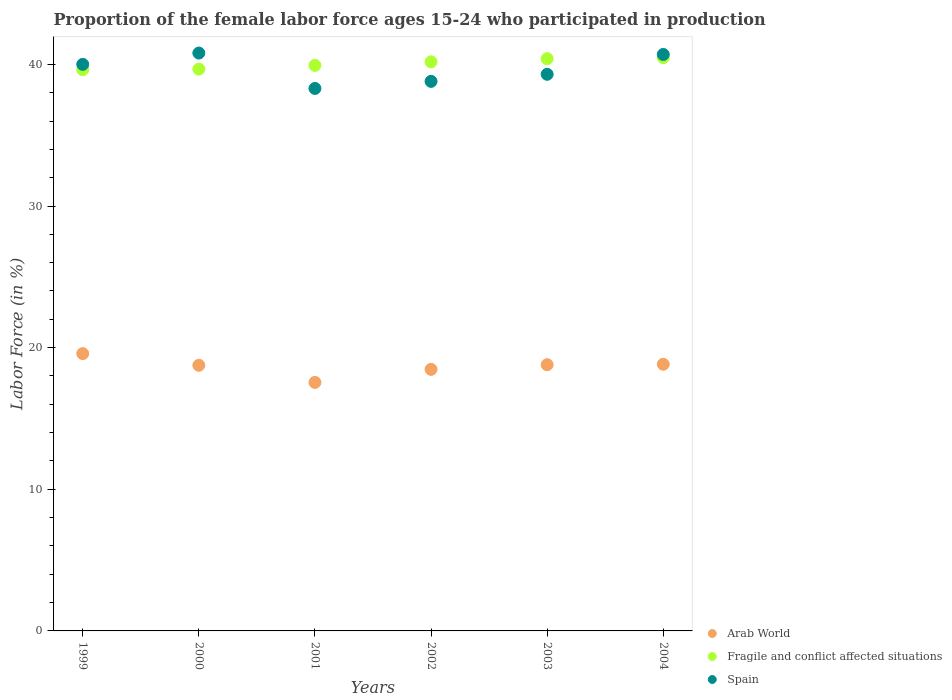How many different coloured dotlines are there?
Ensure brevity in your answer.  3. Is the number of dotlines equal to the number of legend labels?
Give a very brief answer. Yes. What is the proportion of the female labor force who participated in production in Arab World in 1999?
Your response must be concise. 19.58. Across all years, what is the maximum proportion of the female labor force who participated in production in Spain?
Your answer should be compact. 40.8. Across all years, what is the minimum proportion of the female labor force who participated in production in Fragile and conflict affected situations?
Your answer should be very brief. 39.63. In which year was the proportion of the female labor force who participated in production in Arab World maximum?
Make the answer very short. 1999. What is the total proportion of the female labor force who participated in production in Fragile and conflict affected situations in the graph?
Keep it short and to the point. 240.28. What is the difference between the proportion of the female labor force who participated in production in Spain in 2003 and the proportion of the female labor force who participated in production in Arab World in 2001?
Keep it short and to the point. 21.75. What is the average proportion of the female labor force who participated in production in Fragile and conflict affected situations per year?
Provide a succinct answer. 40.05. In the year 2003, what is the difference between the proportion of the female labor force who participated in production in Spain and proportion of the female labor force who participated in production in Arab World?
Offer a terse response. 20.5. What is the ratio of the proportion of the female labor force who participated in production in Spain in 2001 to that in 2004?
Give a very brief answer. 0.94. Is the difference between the proportion of the female labor force who participated in production in Spain in 2000 and 2002 greater than the difference between the proportion of the female labor force who participated in production in Arab World in 2000 and 2002?
Keep it short and to the point. Yes. What is the difference between the highest and the second highest proportion of the female labor force who participated in production in Spain?
Give a very brief answer. 0.1. What is the difference between the highest and the lowest proportion of the female labor force who participated in production in Spain?
Make the answer very short. 2.5. Is the sum of the proportion of the female labor force who participated in production in Fragile and conflict affected situations in 2002 and 2003 greater than the maximum proportion of the female labor force who participated in production in Arab World across all years?
Make the answer very short. Yes. Is it the case that in every year, the sum of the proportion of the female labor force who participated in production in Arab World and proportion of the female labor force who participated in production in Fragile and conflict affected situations  is greater than the proportion of the female labor force who participated in production in Spain?
Your response must be concise. Yes. Does the proportion of the female labor force who participated in production in Spain monotonically increase over the years?
Make the answer very short. No. Is the proportion of the female labor force who participated in production in Fragile and conflict affected situations strictly greater than the proportion of the female labor force who participated in production in Arab World over the years?
Give a very brief answer. Yes. Is the proportion of the female labor force who participated in production in Spain strictly less than the proportion of the female labor force who participated in production in Arab World over the years?
Your answer should be compact. No. How many dotlines are there?
Your answer should be very brief. 3. How many years are there in the graph?
Ensure brevity in your answer.  6. What is the difference between two consecutive major ticks on the Y-axis?
Offer a very short reply. 10. Does the graph contain any zero values?
Provide a succinct answer. No. Does the graph contain grids?
Provide a succinct answer. No. How are the legend labels stacked?
Provide a short and direct response. Vertical. What is the title of the graph?
Provide a short and direct response. Proportion of the female labor force ages 15-24 who participated in production. Does "Pakistan" appear as one of the legend labels in the graph?
Keep it short and to the point. No. What is the label or title of the Y-axis?
Offer a terse response. Labor Force (in %). What is the Labor Force (in %) of Arab World in 1999?
Your answer should be compact. 19.58. What is the Labor Force (in %) in Fragile and conflict affected situations in 1999?
Offer a very short reply. 39.63. What is the Labor Force (in %) in Arab World in 2000?
Give a very brief answer. 18.75. What is the Labor Force (in %) in Fragile and conflict affected situations in 2000?
Provide a short and direct response. 39.67. What is the Labor Force (in %) of Spain in 2000?
Your answer should be compact. 40.8. What is the Labor Force (in %) in Arab World in 2001?
Give a very brief answer. 17.55. What is the Labor Force (in %) of Fragile and conflict affected situations in 2001?
Offer a very short reply. 39.93. What is the Labor Force (in %) in Spain in 2001?
Keep it short and to the point. 38.3. What is the Labor Force (in %) in Arab World in 2002?
Your answer should be very brief. 18.47. What is the Labor Force (in %) of Fragile and conflict affected situations in 2002?
Give a very brief answer. 40.18. What is the Labor Force (in %) in Spain in 2002?
Your response must be concise. 38.8. What is the Labor Force (in %) of Arab World in 2003?
Give a very brief answer. 18.8. What is the Labor Force (in %) in Fragile and conflict affected situations in 2003?
Give a very brief answer. 40.4. What is the Labor Force (in %) of Spain in 2003?
Your answer should be very brief. 39.3. What is the Labor Force (in %) of Arab World in 2004?
Make the answer very short. 18.83. What is the Labor Force (in %) of Fragile and conflict affected situations in 2004?
Your answer should be compact. 40.48. What is the Labor Force (in %) of Spain in 2004?
Keep it short and to the point. 40.7. Across all years, what is the maximum Labor Force (in %) in Arab World?
Keep it short and to the point. 19.58. Across all years, what is the maximum Labor Force (in %) of Fragile and conflict affected situations?
Offer a very short reply. 40.48. Across all years, what is the maximum Labor Force (in %) in Spain?
Keep it short and to the point. 40.8. Across all years, what is the minimum Labor Force (in %) in Arab World?
Your answer should be compact. 17.55. Across all years, what is the minimum Labor Force (in %) in Fragile and conflict affected situations?
Offer a very short reply. 39.63. Across all years, what is the minimum Labor Force (in %) in Spain?
Provide a succinct answer. 38.3. What is the total Labor Force (in %) in Arab World in the graph?
Your answer should be compact. 111.97. What is the total Labor Force (in %) of Fragile and conflict affected situations in the graph?
Your answer should be compact. 240.28. What is the total Labor Force (in %) in Spain in the graph?
Make the answer very short. 237.9. What is the difference between the Labor Force (in %) in Arab World in 1999 and that in 2000?
Your answer should be very brief. 0.83. What is the difference between the Labor Force (in %) in Fragile and conflict affected situations in 1999 and that in 2000?
Provide a short and direct response. -0.04. What is the difference between the Labor Force (in %) in Spain in 1999 and that in 2000?
Make the answer very short. -0.8. What is the difference between the Labor Force (in %) in Arab World in 1999 and that in 2001?
Offer a very short reply. 2.03. What is the difference between the Labor Force (in %) of Fragile and conflict affected situations in 1999 and that in 2001?
Make the answer very short. -0.3. What is the difference between the Labor Force (in %) in Arab World in 1999 and that in 2002?
Offer a very short reply. 1.11. What is the difference between the Labor Force (in %) of Fragile and conflict affected situations in 1999 and that in 2002?
Give a very brief answer. -0.55. What is the difference between the Labor Force (in %) of Arab World in 1999 and that in 2003?
Provide a succinct answer. 0.78. What is the difference between the Labor Force (in %) of Fragile and conflict affected situations in 1999 and that in 2003?
Make the answer very short. -0.78. What is the difference between the Labor Force (in %) in Arab World in 1999 and that in 2004?
Give a very brief answer. 0.75. What is the difference between the Labor Force (in %) in Fragile and conflict affected situations in 1999 and that in 2004?
Provide a succinct answer. -0.85. What is the difference between the Labor Force (in %) of Spain in 1999 and that in 2004?
Give a very brief answer. -0.7. What is the difference between the Labor Force (in %) in Arab World in 2000 and that in 2001?
Ensure brevity in your answer.  1.21. What is the difference between the Labor Force (in %) of Fragile and conflict affected situations in 2000 and that in 2001?
Give a very brief answer. -0.26. What is the difference between the Labor Force (in %) of Arab World in 2000 and that in 2002?
Ensure brevity in your answer.  0.29. What is the difference between the Labor Force (in %) of Fragile and conflict affected situations in 2000 and that in 2002?
Your response must be concise. -0.51. What is the difference between the Labor Force (in %) of Spain in 2000 and that in 2002?
Give a very brief answer. 2. What is the difference between the Labor Force (in %) of Arab World in 2000 and that in 2003?
Your answer should be compact. -0.04. What is the difference between the Labor Force (in %) of Fragile and conflict affected situations in 2000 and that in 2003?
Your response must be concise. -0.73. What is the difference between the Labor Force (in %) of Spain in 2000 and that in 2003?
Provide a short and direct response. 1.5. What is the difference between the Labor Force (in %) in Arab World in 2000 and that in 2004?
Ensure brevity in your answer.  -0.07. What is the difference between the Labor Force (in %) in Fragile and conflict affected situations in 2000 and that in 2004?
Ensure brevity in your answer.  -0.81. What is the difference between the Labor Force (in %) in Spain in 2000 and that in 2004?
Provide a succinct answer. 0.1. What is the difference between the Labor Force (in %) in Arab World in 2001 and that in 2002?
Your answer should be compact. -0.92. What is the difference between the Labor Force (in %) of Fragile and conflict affected situations in 2001 and that in 2002?
Offer a very short reply. -0.25. What is the difference between the Labor Force (in %) of Spain in 2001 and that in 2002?
Your answer should be very brief. -0.5. What is the difference between the Labor Force (in %) of Arab World in 2001 and that in 2003?
Your response must be concise. -1.25. What is the difference between the Labor Force (in %) in Fragile and conflict affected situations in 2001 and that in 2003?
Offer a very short reply. -0.47. What is the difference between the Labor Force (in %) of Spain in 2001 and that in 2003?
Make the answer very short. -1. What is the difference between the Labor Force (in %) in Arab World in 2001 and that in 2004?
Offer a very short reply. -1.28. What is the difference between the Labor Force (in %) of Fragile and conflict affected situations in 2001 and that in 2004?
Offer a terse response. -0.55. What is the difference between the Labor Force (in %) of Spain in 2001 and that in 2004?
Provide a short and direct response. -2.4. What is the difference between the Labor Force (in %) of Arab World in 2002 and that in 2003?
Keep it short and to the point. -0.33. What is the difference between the Labor Force (in %) in Fragile and conflict affected situations in 2002 and that in 2003?
Ensure brevity in your answer.  -0.22. What is the difference between the Labor Force (in %) in Arab World in 2002 and that in 2004?
Your answer should be very brief. -0.36. What is the difference between the Labor Force (in %) of Fragile and conflict affected situations in 2002 and that in 2004?
Provide a succinct answer. -0.3. What is the difference between the Labor Force (in %) in Arab World in 2003 and that in 2004?
Offer a terse response. -0.03. What is the difference between the Labor Force (in %) of Fragile and conflict affected situations in 2003 and that in 2004?
Give a very brief answer. -0.08. What is the difference between the Labor Force (in %) of Arab World in 1999 and the Labor Force (in %) of Fragile and conflict affected situations in 2000?
Provide a succinct answer. -20.09. What is the difference between the Labor Force (in %) in Arab World in 1999 and the Labor Force (in %) in Spain in 2000?
Provide a succinct answer. -21.22. What is the difference between the Labor Force (in %) of Fragile and conflict affected situations in 1999 and the Labor Force (in %) of Spain in 2000?
Offer a terse response. -1.17. What is the difference between the Labor Force (in %) of Arab World in 1999 and the Labor Force (in %) of Fragile and conflict affected situations in 2001?
Offer a terse response. -20.35. What is the difference between the Labor Force (in %) in Arab World in 1999 and the Labor Force (in %) in Spain in 2001?
Your answer should be compact. -18.72. What is the difference between the Labor Force (in %) in Fragile and conflict affected situations in 1999 and the Labor Force (in %) in Spain in 2001?
Keep it short and to the point. 1.33. What is the difference between the Labor Force (in %) in Arab World in 1999 and the Labor Force (in %) in Fragile and conflict affected situations in 2002?
Provide a succinct answer. -20.6. What is the difference between the Labor Force (in %) in Arab World in 1999 and the Labor Force (in %) in Spain in 2002?
Provide a short and direct response. -19.22. What is the difference between the Labor Force (in %) of Fragile and conflict affected situations in 1999 and the Labor Force (in %) of Spain in 2002?
Your answer should be compact. 0.83. What is the difference between the Labor Force (in %) of Arab World in 1999 and the Labor Force (in %) of Fragile and conflict affected situations in 2003?
Make the answer very short. -20.82. What is the difference between the Labor Force (in %) in Arab World in 1999 and the Labor Force (in %) in Spain in 2003?
Offer a terse response. -19.72. What is the difference between the Labor Force (in %) of Fragile and conflict affected situations in 1999 and the Labor Force (in %) of Spain in 2003?
Give a very brief answer. 0.33. What is the difference between the Labor Force (in %) in Arab World in 1999 and the Labor Force (in %) in Fragile and conflict affected situations in 2004?
Keep it short and to the point. -20.9. What is the difference between the Labor Force (in %) in Arab World in 1999 and the Labor Force (in %) in Spain in 2004?
Make the answer very short. -21.12. What is the difference between the Labor Force (in %) of Fragile and conflict affected situations in 1999 and the Labor Force (in %) of Spain in 2004?
Provide a short and direct response. -1.07. What is the difference between the Labor Force (in %) in Arab World in 2000 and the Labor Force (in %) in Fragile and conflict affected situations in 2001?
Your answer should be very brief. -21.18. What is the difference between the Labor Force (in %) in Arab World in 2000 and the Labor Force (in %) in Spain in 2001?
Keep it short and to the point. -19.55. What is the difference between the Labor Force (in %) in Fragile and conflict affected situations in 2000 and the Labor Force (in %) in Spain in 2001?
Your answer should be very brief. 1.37. What is the difference between the Labor Force (in %) in Arab World in 2000 and the Labor Force (in %) in Fragile and conflict affected situations in 2002?
Ensure brevity in your answer.  -21.43. What is the difference between the Labor Force (in %) in Arab World in 2000 and the Labor Force (in %) in Spain in 2002?
Ensure brevity in your answer.  -20.05. What is the difference between the Labor Force (in %) in Fragile and conflict affected situations in 2000 and the Labor Force (in %) in Spain in 2002?
Ensure brevity in your answer.  0.87. What is the difference between the Labor Force (in %) in Arab World in 2000 and the Labor Force (in %) in Fragile and conflict affected situations in 2003?
Offer a very short reply. -21.65. What is the difference between the Labor Force (in %) of Arab World in 2000 and the Labor Force (in %) of Spain in 2003?
Provide a succinct answer. -20.55. What is the difference between the Labor Force (in %) of Fragile and conflict affected situations in 2000 and the Labor Force (in %) of Spain in 2003?
Provide a succinct answer. 0.37. What is the difference between the Labor Force (in %) of Arab World in 2000 and the Labor Force (in %) of Fragile and conflict affected situations in 2004?
Your answer should be very brief. -21.73. What is the difference between the Labor Force (in %) in Arab World in 2000 and the Labor Force (in %) in Spain in 2004?
Give a very brief answer. -21.95. What is the difference between the Labor Force (in %) of Fragile and conflict affected situations in 2000 and the Labor Force (in %) of Spain in 2004?
Keep it short and to the point. -1.03. What is the difference between the Labor Force (in %) in Arab World in 2001 and the Labor Force (in %) in Fragile and conflict affected situations in 2002?
Provide a short and direct response. -22.63. What is the difference between the Labor Force (in %) of Arab World in 2001 and the Labor Force (in %) of Spain in 2002?
Offer a terse response. -21.25. What is the difference between the Labor Force (in %) of Fragile and conflict affected situations in 2001 and the Labor Force (in %) of Spain in 2002?
Offer a very short reply. 1.13. What is the difference between the Labor Force (in %) in Arab World in 2001 and the Labor Force (in %) in Fragile and conflict affected situations in 2003?
Make the answer very short. -22.86. What is the difference between the Labor Force (in %) of Arab World in 2001 and the Labor Force (in %) of Spain in 2003?
Your answer should be very brief. -21.75. What is the difference between the Labor Force (in %) of Fragile and conflict affected situations in 2001 and the Labor Force (in %) of Spain in 2003?
Provide a succinct answer. 0.63. What is the difference between the Labor Force (in %) of Arab World in 2001 and the Labor Force (in %) of Fragile and conflict affected situations in 2004?
Provide a succinct answer. -22.93. What is the difference between the Labor Force (in %) in Arab World in 2001 and the Labor Force (in %) in Spain in 2004?
Provide a succinct answer. -23.15. What is the difference between the Labor Force (in %) in Fragile and conflict affected situations in 2001 and the Labor Force (in %) in Spain in 2004?
Provide a succinct answer. -0.77. What is the difference between the Labor Force (in %) of Arab World in 2002 and the Labor Force (in %) of Fragile and conflict affected situations in 2003?
Your answer should be compact. -21.93. What is the difference between the Labor Force (in %) of Arab World in 2002 and the Labor Force (in %) of Spain in 2003?
Provide a short and direct response. -20.83. What is the difference between the Labor Force (in %) in Fragile and conflict affected situations in 2002 and the Labor Force (in %) in Spain in 2003?
Make the answer very short. 0.88. What is the difference between the Labor Force (in %) of Arab World in 2002 and the Labor Force (in %) of Fragile and conflict affected situations in 2004?
Your response must be concise. -22.01. What is the difference between the Labor Force (in %) of Arab World in 2002 and the Labor Force (in %) of Spain in 2004?
Make the answer very short. -22.23. What is the difference between the Labor Force (in %) in Fragile and conflict affected situations in 2002 and the Labor Force (in %) in Spain in 2004?
Your answer should be compact. -0.52. What is the difference between the Labor Force (in %) in Arab World in 2003 and the Labor Force (in %) in Fragile and conflict affected situations in 2004?
Provide a short and direct response. -21.68. What is the difference between the Labor Force (in %) of Arab World in 2003 and the Labor Force (in %) of Spain in 2004?
Offer a terse response. -21.9. What is the difference between the Labor Force (in %) of Fragile and conflict affected situations in 2003 and the Labor Force (in %) of Spain in 2004?
Your response must be concise. -0.3. What is the average Labor Force (in %) of Arab World per year?
Keep it short and to the point. 18.66. What is the average Labor Force (in %) in Fragile and conflict affected situations per year?
Ensure brevity in your answer.  40.05. What is the average Labor Force (in %) in Spain per year?
Ensure brevity in your answer.  39.65. In the year 1999, what is the difference between the Labor Force (in %) of Arab World and Labor Force (in %) of Fragile and conflict affected situations?
Your response must be concise. -20.05. In the year 1999, what is the difference between the Labor Force (in %) in Arab World and Labor Force (in %) in Spain?
Your answer should be very brief. -20.42. In the year 1999, what is the difference between the Labor Force (in %) of Fragile and conflict affected situations and Labor Force (in %) of Spain?
Provide a short and direct response. -0.37. In the year 2000, what is the difference between the Labor Force (in %) of Arab World and Labor Force (in %) of Fragile and conflict affected situations?
Provide a short and direct response. -20.91. In the year 2000, what is the difference between the Labor Force (in %) of Arab World and Labor Force (in %) of Spain?
Keep it short and to the point. -22.05. In the year 2000, what is the difference between the Labor Force (in %) of Fragile and conflict affected situations and Labor Force (in %) of Spain?
Your answer should be very brief. -1.13. In the year 2001, what is the difference between the Labor Force (in %) of Arab World and Labor Force (in %) of Fragile and conflict affected situations?
Offer a terse response. -22.38. In the year 2001, what is the difference between the Labor Force (in %) in Arab World and Labor Force (in %) in Spain?
Give a very brief answer. -20.75. In the year 2001, what is the difference between the Labor Force (in %) of Fragile and conflict affected situations and Labor Force (in %) of Spain?
Your answer should be very brief. 1.63. In the year 2002, what is the difference between the Labor Force (in %) of Arab World and Labor Force (in %) of Fragile and conflict affected situations?
Your response must be concise. -21.71. In the year 2002, what is the difference between the Labor Force (in %) of Arab World and Labor Force (in %) of Spain?
Provide a short and direct response. -20.33. In the year 2002, what is the difference between the Labor Force (in %) in Fragile and conflict affected situations and Labor Force (in %) in Spain?
Offer a terse response. 1.38. In the year 2003, what is the difference between the Labor Force (in %) of Arab World and Labor Force (in %) of Fragile and conflict affected situations?
Your answer should be compact. -21.61. In the year 2003, what is the difference between the Labor Force (in %) of Arab World and Labor Force (in %) of Spain?
Your response must be concise. -20.5. In the year 2003, what is the difference between the Labor Force (in %) of Fragile and conflict affected situations and Labor Force (in %) of Spain?
Your response must be concise. 1.1. In the year 2004, what is the difference between the Labor Force (in %) in Arab World and Labor Force (in %) in Fragile and conflict affected situations?
Your response must be concise. -21.65. In the year 2004, what is the difference between the Labor Force (in %) of Arab World and Labor Force (in %) of Spain?
Keep it short and to the point. -21.87. In the year 2004, what is the difference between the Labor Force (in %) of Fragile and conflict affected situations and Labor Force (in %) of Spain?
Your answer should be very brief. -0.22. What is the ratio of the Labor Force (in %) of Arab World in 1999 to that in 2000?
Ensure brevity in your answer.  1.04. What is the ratio of the Labor Force (in %) in Spain in 1999 to that in 2000?
Offer a terse response. 0.98. What is the ratio of the Labor Force (in %) in Arab World in 1999 to that in 2001?
Your response must be concise. 1.12. What is the ratio of the Labor Force (in %) of Fragile and conflict affected situations in 1999 to that in 2001?
Make the answer very short. 0.99. What is the ratio of the Labor Force (in %) of Spain in 1999 to that in 2001?
Your response must be concise. 1.04. What is the ratio of the Labor Force (in %) in Arab World in 1999 to that in 2002?
Your answer should be compact. 1.06. What is the ratio of the Labor Force (in %) in Fragile and conflict affected situations in 1999 to that in 2002?
Give a very brief answer. 0.99. What is the ratio of the Labor Force (in %) in Spain in 1999 to that in 2002?
Your answer should be compact. 1.03. What is the ratio of the Labor Force (in %) in Arab World in 1999 to that in 2003?
Offer a terse response. 1.04. What is the ratio of the Labor Force (in %) in Fragile and conflict affected situations in 1999 to that in 2003?
Provide a succinct answer. 0.98. What is the ratio of the Labor Force (in %) of Spain in 1999 to that in 2003?
Your answer should be very brief. 1.02. What is the ratio of the Labor Force (in %) in Arab World in 1999 to that in 2004?
Ensure brevity in your answer.  1.04. What is the ratio of the Labor Force (in %) of Fragile and conflict affected situations in 1999 to that in 2004?
Your answer should be very brief. 0.98. What is the ratio of the Labor Force (in %) in Spain in 1999 to that in 2004?
Keep it short and to the point. 0.98. What is the ratio of the Labor Force (in %) in Arab World in 2000 to that in 2001?
Ensure brevity in your answer.  1.07. What is the ratio of the Labor Force (in %) of Fragile and conflict affected situations in 2000 to that in 2001?
Your answer should be very brief. 0.99. What is the ratio of the Labor Force (in %) in Spain in 2000 to that in 2001?
Offer a terse response. 1.07. What is the ratio of the Labor Force (in %) in Arab World in 2000 to that in 2002?
Your answer should be compact. 1.02. What is the ratio of the Labor Force (in %) in Fragile and conflict affected situations in 2000 to that in 2002?
Offer a very short reply. 0.99. What is the ratio of the Labor Force (in %) in Spain in 2000 to that in 2002?
Give a very brief answer. 1.05. What is the ratio of the Labor Force (in %) in Fragile and conflict affected situations in 2000 to that in 2003?
Your answer should be very brief. 0.98. What is the ratio of the Labor Force (in %) in Spain in 2000 to that in 2003?
Your response must be concise. 1.04. What is the ratio of the Labor Force (in %) in Fragile and conflict affected situations in 2000 to that in 2004?
Offer a very short reply. 0.98. What is the ratio of the Labor Force (in %) in Arab World in 2001 to that in 2002?
Provide a succinct answer. 0.95. What is the ratio of the Labor Force (in %) of Fragile and conflict affected situations in 2001 to that in 2002?
Make the answer very short. 0.99. What is the ratio of the Labor Force (in %) of Spain in 2001 to that in 2002?
Keep it short and to the point. 0.99. What is the ratio of the Labor Force (in %) of Arab World in 2001 to that in 2003?
Keep it short and to the point. 0.93. What is the ratio of the Labor Force (in %) in Fragile and conflict affected situations in 2001 to that in 2003?
Ensure brevity in your answer.  0.99. What is the ratio of the Labor Force (in %) of Spain in 2001 to that in 2003?
Ensure brevity in your answer.  0.97. What is the ratio of the Labor Force (in %) of Arab World in 2001 to that in 2004?
Keep it short and to the point. 0.93. What is the ratio of the Labor Force (in %) in Fragile and conflict affected situations in 2001 to that in 2004?
Ensure brevity in your answer.  0.99. What is the ratio of the Labor Force (in %) of Spain in 2001 to that in 2004?
Offer a very short reply. 0.94. What is the ratio of the Labor Force (in %) of Arab World in 2002 to that in 2003?
Make the answer very short. 0.98. What is the ratio of the Labor Force (in %) in Fragile and conflict affected situations in 2002 to that in 2003?
Your answer should be compact. 0.99. What is the ratio of the Labor Force (in %) of Spain in 2002 to that in 2003?
Keep it short and to the point. 0.99. What is the ratio of the Labor Force (in %) in Arab World in 2002 to that in 2004?
Offer a terse response. 0.98. What is the ratio of the Labor Force (in %) in Fragile and conflict affected situations in 2002 to that in 2004?
Your response must be concise. 0.99. What is the ratio of the Labor Force (in %) of Spain in 2002 to that in 2004?
Ensure brevity in your answer.  0.95. What is the ratio of the Labor Force (in %) of Arab World in 2003 to that in 2004?
Offer a terse response. 1. What is the ratio of the Labor Force (in %) in Fragile and conflict affected situations in 2003 to that in 2004?
Your response must be concise. 1. What is the ratio of the Labor Force (in %) in Spain in 2003 to that in 2004?
Give a very brief answer. 0.97. What is the difference between the highest and the second highest Labor Force (in %) of Arab World?
Provide a short and direct response. 0.75. What is the difference between the highest and the second highest Labor Force (in %) of Fragile and conflict affected situations?
Your answer should be very brief. 0.08. What is the difference between the highest and the lowest Labor Force (in %) of Arab World?
Offer a very short reply. 2.03. What is the difference between the highest and the lowest Labor Force (in %) in Fragile and conflict affected situations?
Keep it short and to the point. 0.85. What is the difference between the highest and the lowest Labor Force (in %) in Spain?
Provide a short and direct response. 2.5. 